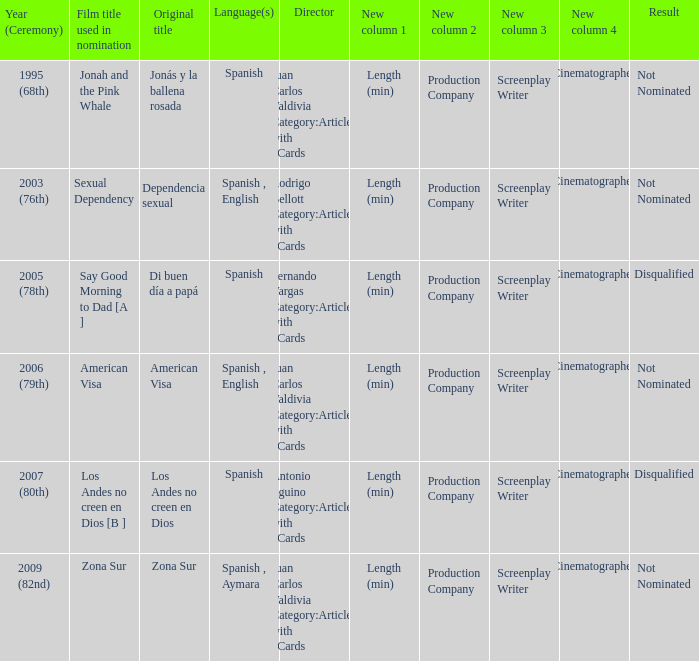What was the result for zona sur after being taken into account for nomination? Not Nominated. 